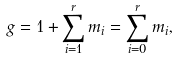Convert formula to latex. <formula><loc_0><loc_0><loc_500><loc_500>g = 1 + \sum _ { i = 1 } ^ { r } m _ { i } = \sum _ { i = 0 } ^ { r } m _ { i } ,</formula> 